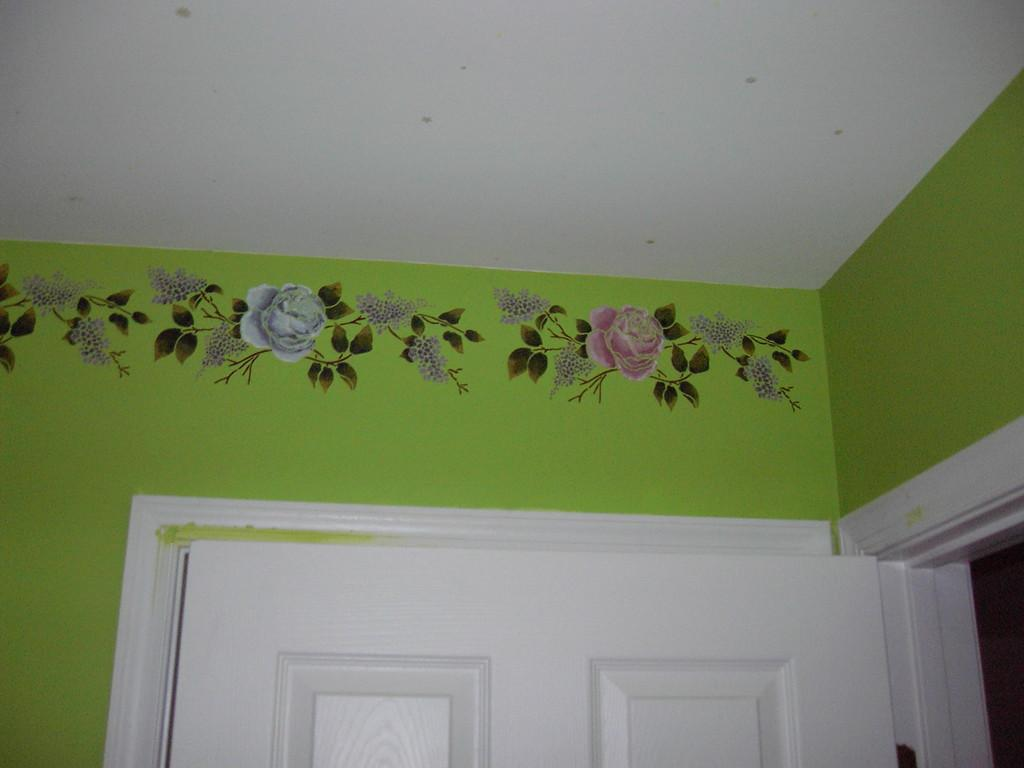What is present on the wall in the image? There is a design on the wall in the image. Can you describe the design on the wall? Unfortunately, the facts provided do not give a detailed description of the design on the wall. What other feature can be seen on the wall? There is a door in the image. How many feet are visible on the wall in the image? There are no feet present on the wall in the image. Is there a mask hanging on the wall in the image? There is no mention of a mask in the provided facts, so we cannot confirm its presence in the image. 